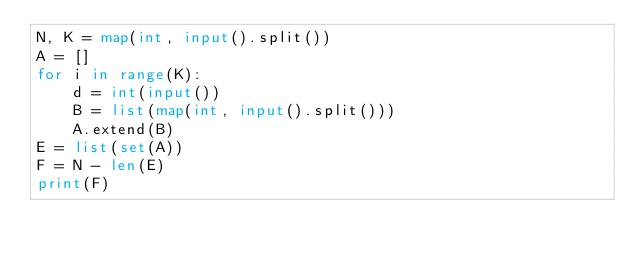<code> <loc_0><loc_0><loc_500><loc_500><_Python_>N, K = map(int, input().split())
A = []
for i in range(K):
    d = int(input())
    B = list(map(int, input().split()))
    A.extend(B)
E = list(set(A))
F = N - len(E)
print(F)</code> 